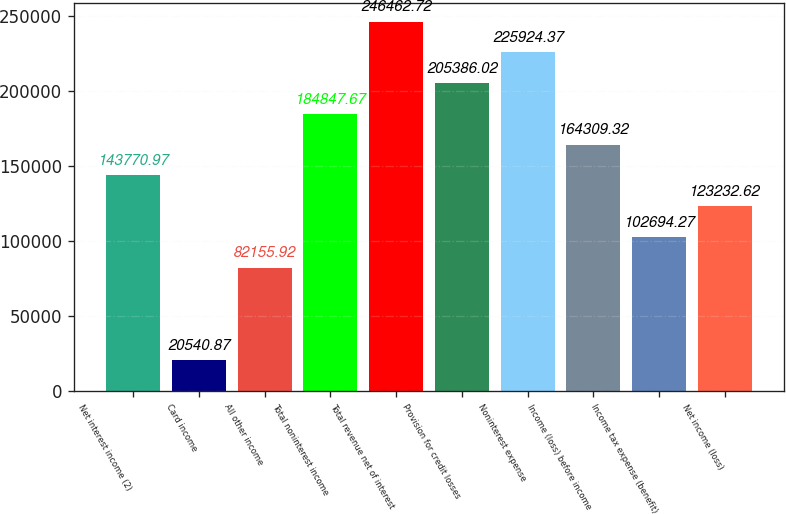Convert chart. <chart><loc_0><loc_0><loc_500><loc_500><bar_chart><fcel>Net interest income (2)<fcel>Card income<fcel>All other income<fcel>Total noninterest income<fcel>Total revenue net of interest<fcel>Provision for credit losses<fcel>Noninterest expense<fcel>Income (loss) before income<fcel>Income tax expense (benefit)<fcel>Net income (loss)<nl><fcel>143771<fcel>20540.9<fcel>82155.9<fcel>184848<fcel>246463<fcel>205386<fcel>225924<fcel>164309<fcel>102694<fcel>123233<nl></chart> 